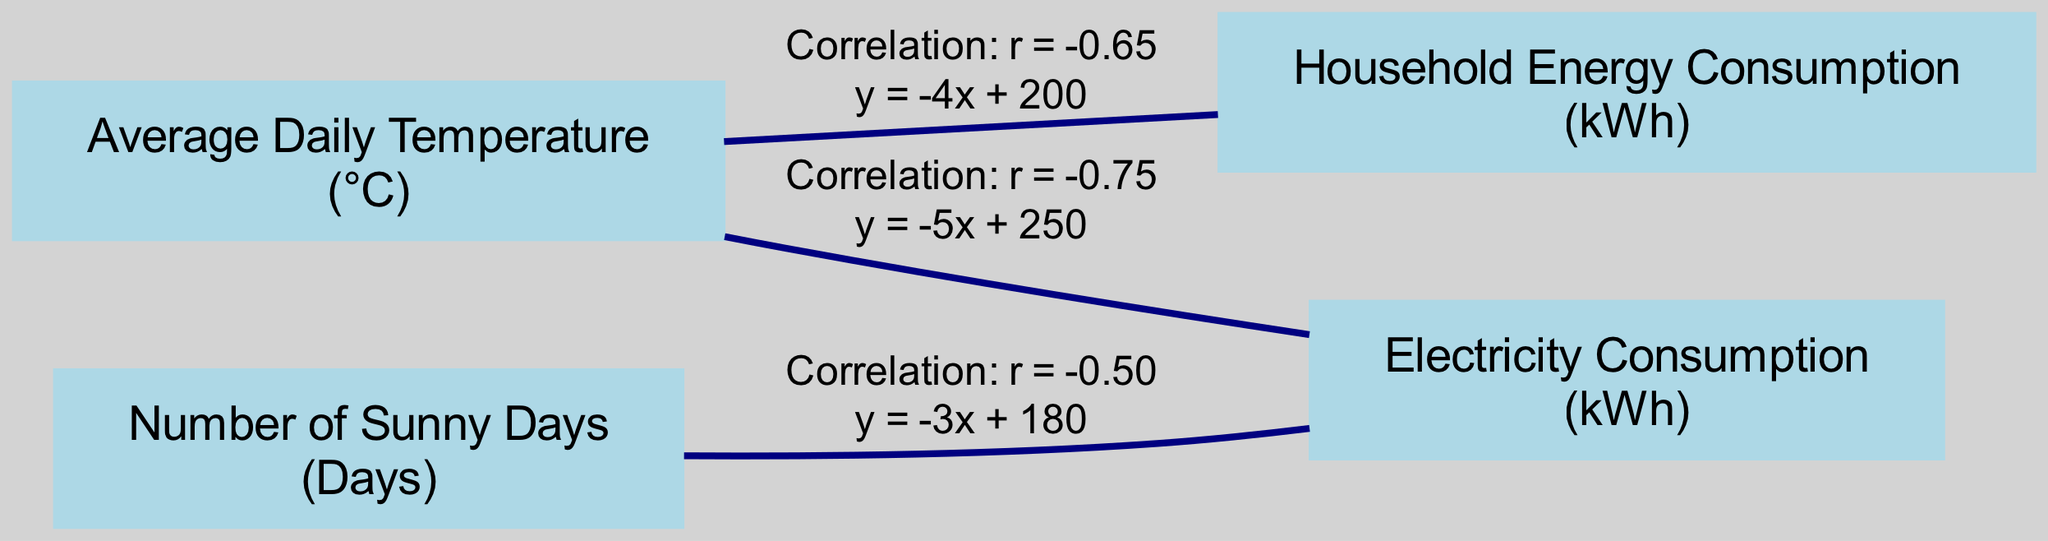What is the label of the node representing average daily temperature? The node representing average daily temperature has the label "Average Daily Temperature". This can be found by looking at the first node in the diagram.
Answer: Average Daily Temperature What is the regression line for the relationship between average daily temperature and electricity consumption? The edge connecting average daily temperature to electricity consumption provides the regression line, which is "y = -5x + 250". This is listed in the label of the edge between these two nodes.
Answer: y = -5x + 250 How many nodes are present in this diagram? To find the number of nodes, we count each unique node listed in the diagram. There are four nodes: Average Daily Temperature, Electricity Consumption, Household Energy Consumption, and Number of Sunny Days.
Answer: 4 What is the correlation coefficient between average daily temperature and household energy consumption? The edge connecting average daily temperature and household energy consumption shows a correlation coefficient of "r = -0.65". This information is found in the label on the edge connecting these two nodes.
Answer: -0.65 Which variable shows the strongest negative correlation with electricity consumption? To determine which variable shows the strongest negative correlation with electricity consumption, we compare the correlation coefficients listed. The strongest correlation is "r = -0.75" with average daily temperature, as it has the highest absolute value.
Answer: Average Daily Temperature What is the unit of measurement for household energy consumption? The unit of measurement for household energy consumption is specified in parentheses next to the node label. It is "kWh".
Answer: kWh What is the label of the edge between the number of sunny days and electricity consumption? By examining the diagram, the edge that connects the number of sunny days to electricity consumption has the label "Correlation: r = -0.50". This detail can be seen in the edge connecting these two nodes.
Answer: Correlation: r = -0.50 What is the regression line associated with the relationship between the number of sunny days and electricity consumption? The edge linking the number of sunny days to electricity consumption provides the regression line, which is "y = -3x + 180". This regression line is found within the label of that edge.
Answer: y = -3x + 180 Which two variables have the same unit of measurement? To find which variables have the same unit, we can look at the units listed next to each node. Both electricity consumption and household energy consumption share the unit "kWh".
Answer: electricity consumption, household energy consumption 